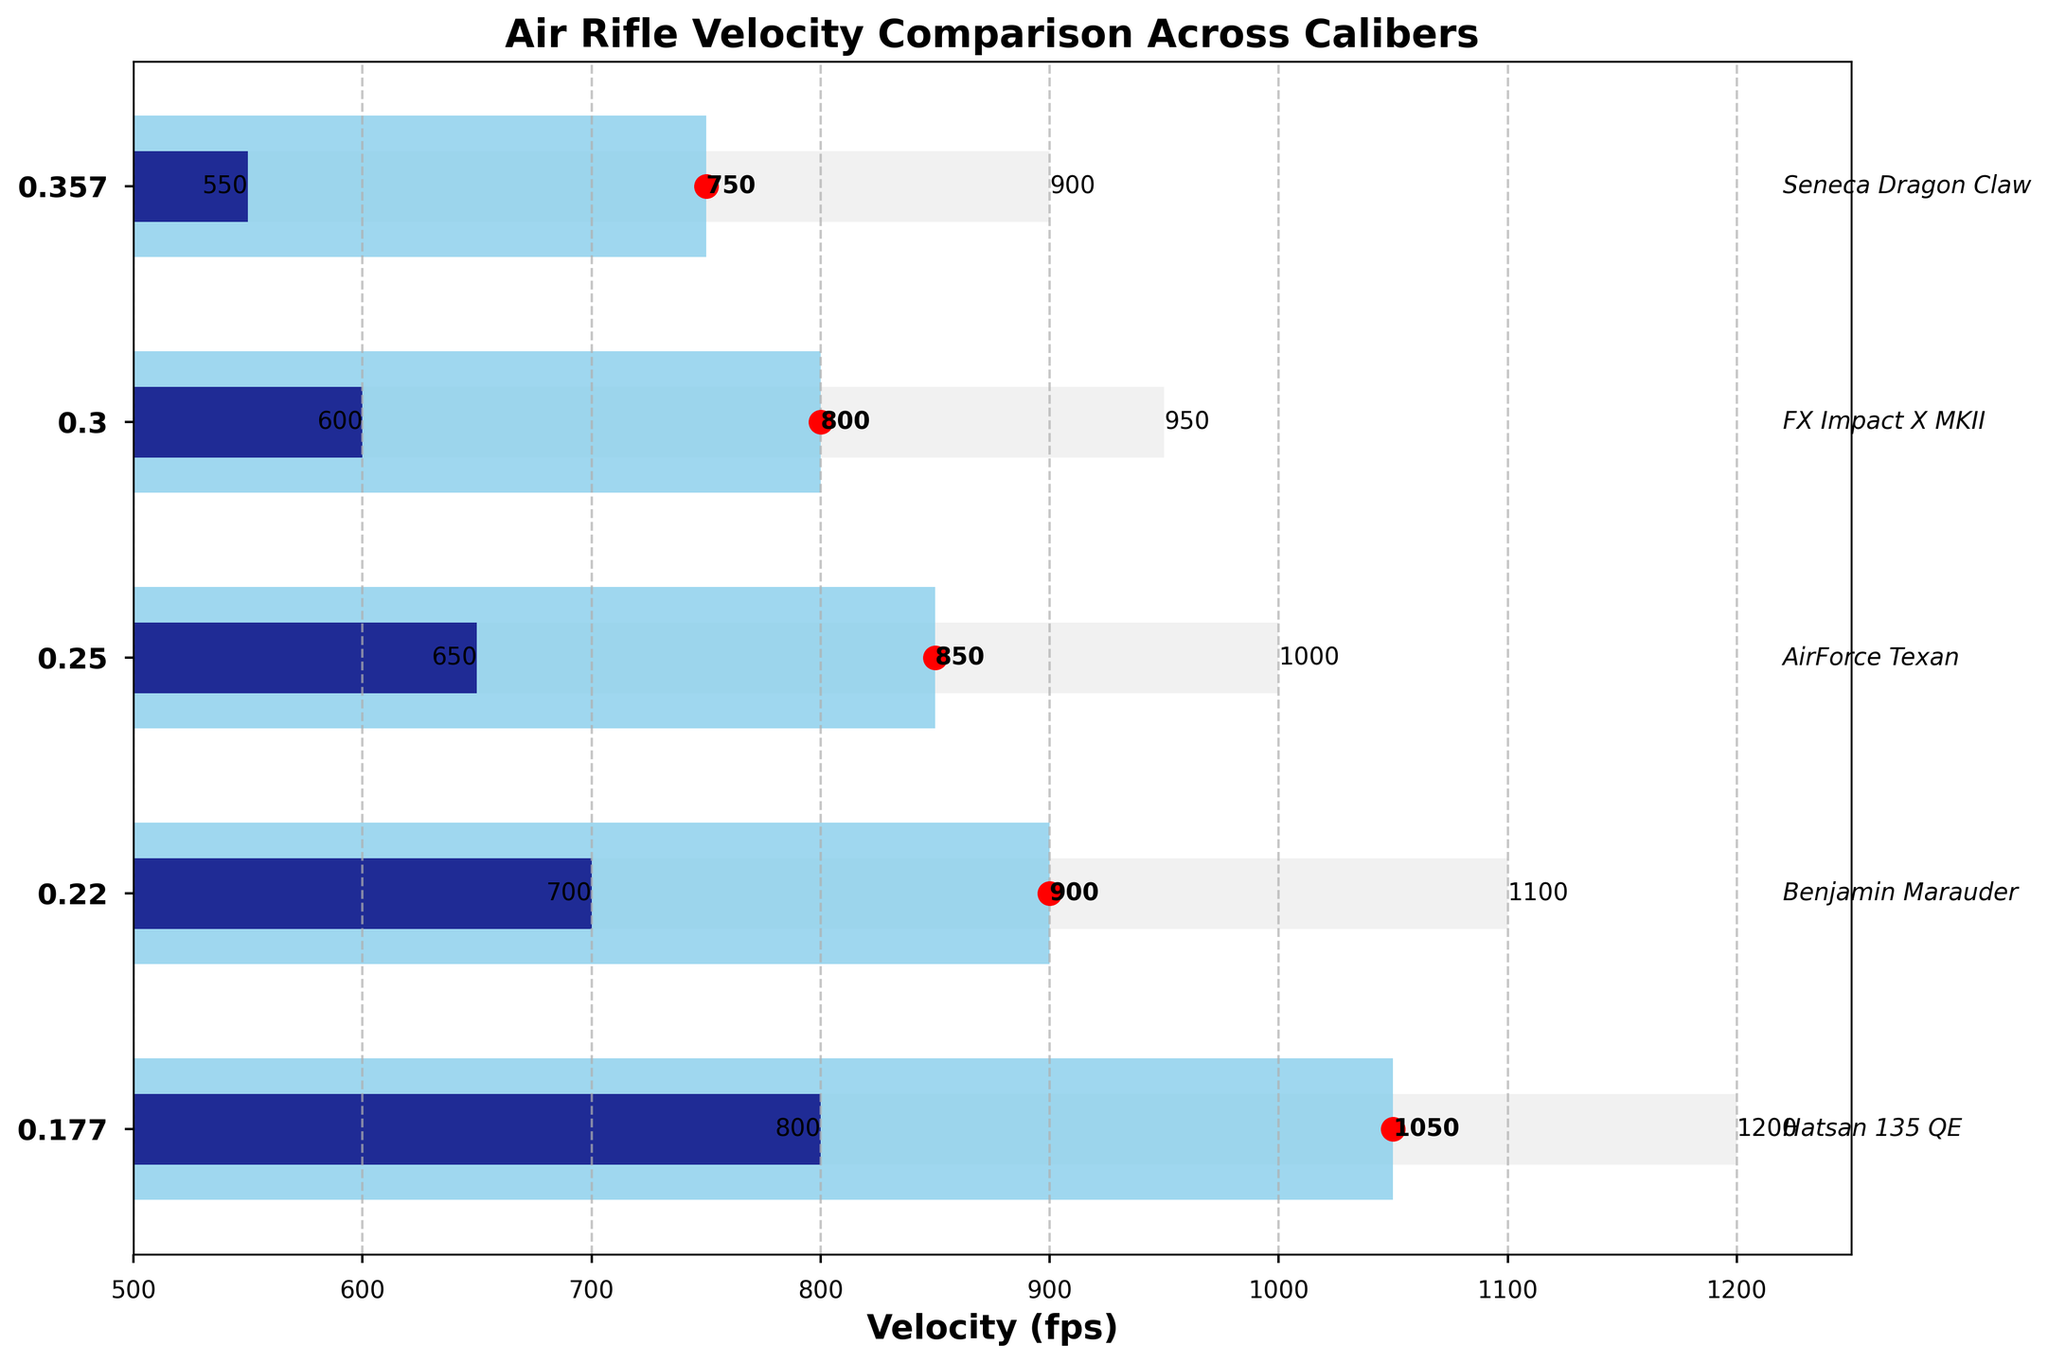How many calibers are represented in the plot? The y-axis labels indicate the different calibers. By counting the labels, we can determine there are 5 calibers.
Answer: 5 Which caliber has the highest average velocity? The average velocities are indicated by the central blue bars and the red markers. The longest blue bar and the highest red marker are for the .177 caliber with an average velocity of 1050 fps.
Answer: .177 What is the range of velocities for the .30 caliber? The range can be found by subtracting the minimum velocity from the maximum velocity for the .30 caliber, which are 600 fps and 950 fps respectively. So, 950 - 600 = 350 fps.
Answer: 350 fps Compare the maximum velocities of .25 and .22 calibers. Which one is higher? The maximum velocities are shown by the light grey bars. The maximum velocity for the .25 caliber is 1000 fps, and for the .22 caliber is 1100 fps. 1100 fps is higher than 1000 fps.
Answer: .22 Which air rifle is the top performer for the .357 caliber? The top performer air rifle names are written next to each caliber. For the .357 caliber, the top performer is "Seneca Dragon Claw."
Answer: Seneca Dragon Claw What is the difference between the minimum and maximum velocities for the .177 caliber? The minimum and maximum velocities are labeled on the horizontal bars. For the .177 caliber, the minimum is 800 fps and the maximum is 1200 fps. The difference is 1200 - 800 = 400 fps.
Answer: 400 fps Which caliber has the smallest range of velocities? The range is the difference between the maximum and minimum velocities. For each caliber, calculate the range and compare: 
.177: 1200 - 800 = 400 fps,
.22: 1100 - 700 = 400 fps,
.25: 1000 - 650 = 350 fps,
.30: 950 - 600 = 350 fps,
.357: 900 - 550 = 350 fps.
Several calibers have the smallest range of 350 fps.
Answer: .25, .30, .357 How many calibers have an average velocity above 800 fps? The average velocities are indicated by the positions of the red markers. Count the calibers with average velocities above 800 fps from the chart:
.177 (1050 fps) - above
.22 (900 fps) - above
.25 (850 fps) - above
.30 (800 fps) - at 800 (not above)
.357 (750 fps) - below
So, 3 calibers have velocities above 800 fps.
Answer: 3 